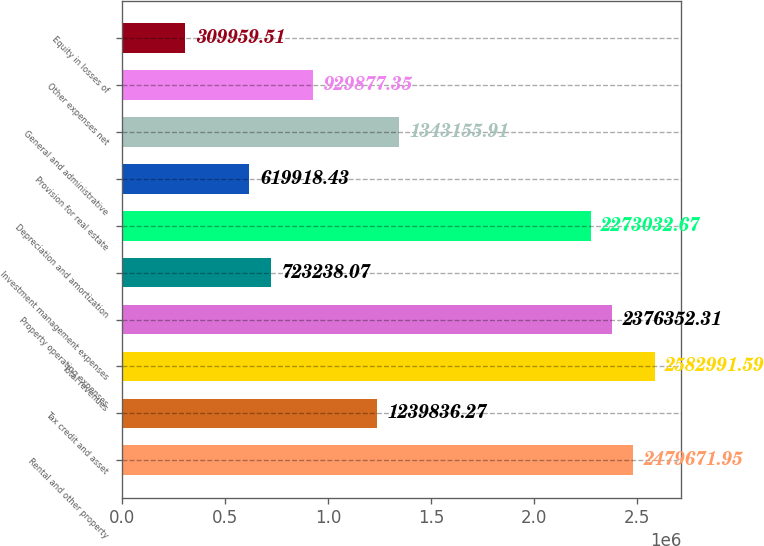Convert chart to OTSL. <chart><loc_0><loc_0><loc_500><loc_500><bar_chart><fcel>Rental and other property<fcel>Tax credit and asset<fcel>Total revenues<fcel>Property operating expenses<fcel>Investment management expenses<fcel>Depreciation and amortization<fcel>Provision for real estate<fcel>General and administrative<fcel>Other expenses net<fcel>Equity in losses of<nl><fcel>2.47967e+06<fcel>1.23984e+06<fcel>2.58299e+06<fcel>2.37635e+06<fcel>723238<fcel>2.27303e+06<fcel>619918<fcel>1.34316e+06<fcel>929877<fcel>309960<nl></chart> 